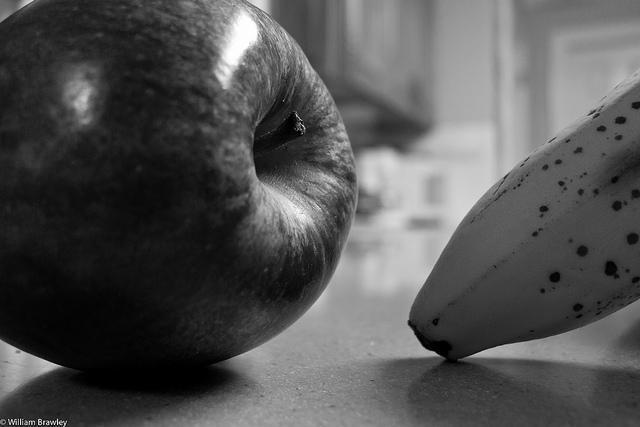Does the description: "The apple is connected to the dining table." accurately reflect the image?
Answer yes or no. Yes. 